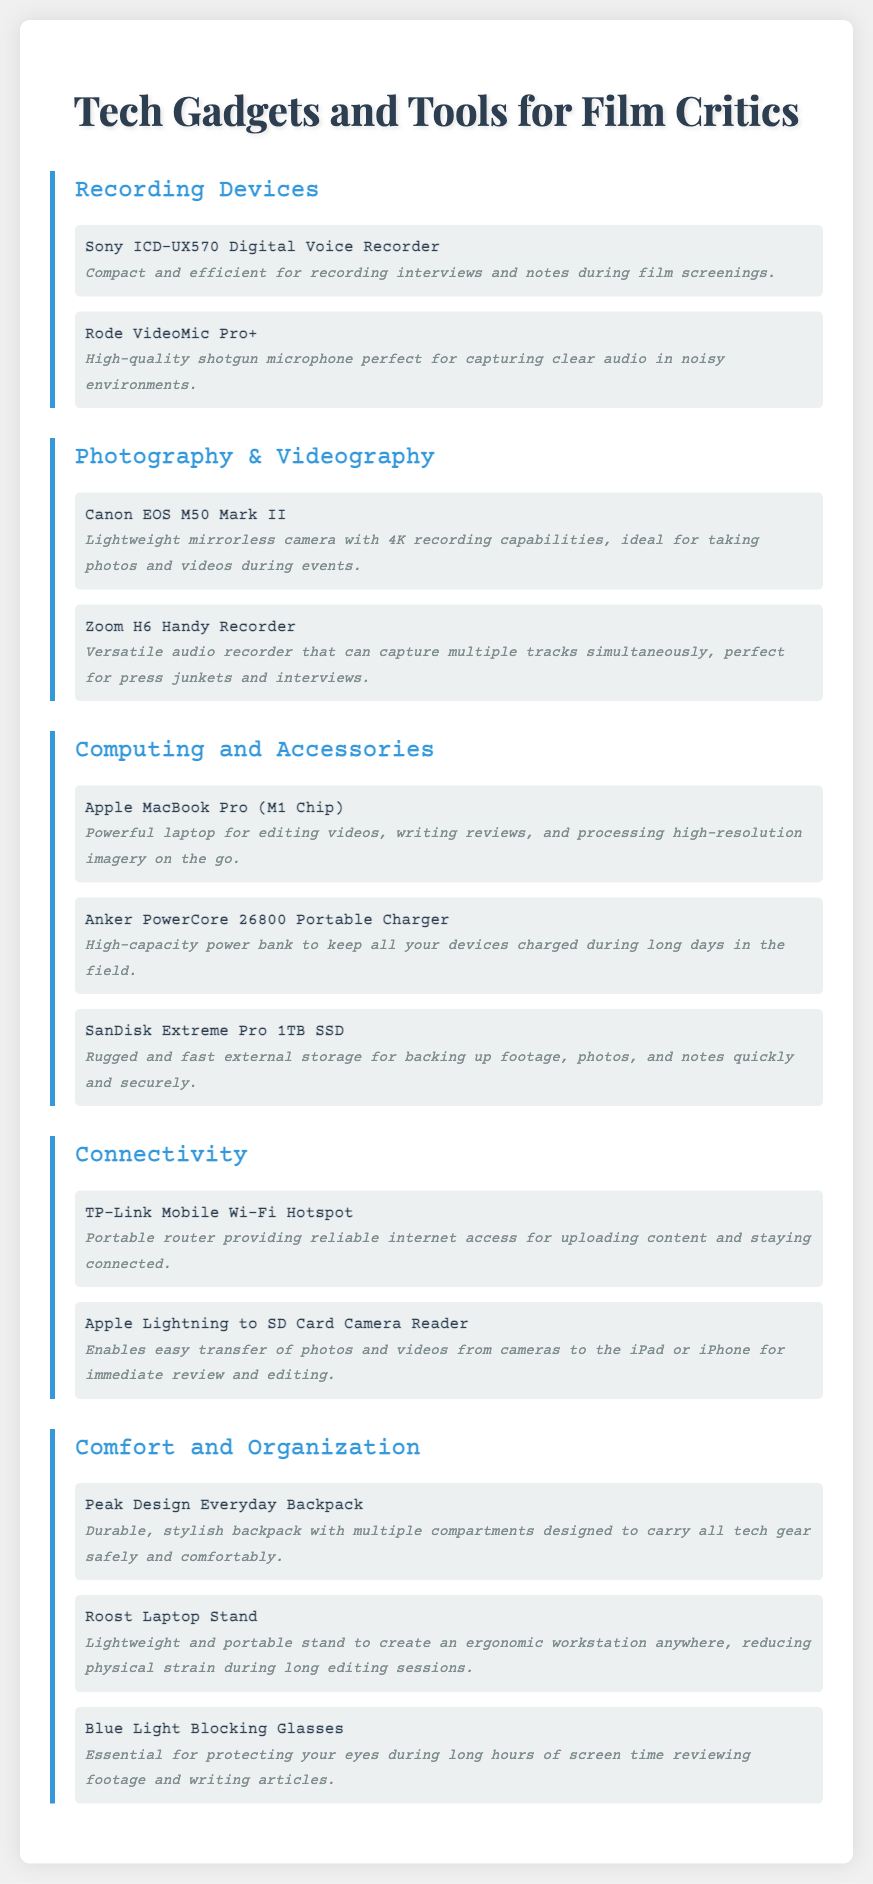what recording device is recommended for interviews? The document lists the Sony ICD-UX570 Digital Voice Recorder as a compact and efficient device for recording interviews.
Answer: Sony ICD-UX570 Digital Voice Recorder which camera is noted for 4K recording capabilities? The Canon EOS M50 Mark II is highlighted for its 4K recording capabilities.
Answer: Canon EOS M50 Mark II how many items are listed under Computing and Accessories? The document mentions three items under the Computing and Accessories category.
Answer: 3 what is the portable router mentioned for internet access? The TP-Link Mobile Wi-Fi Hotspot is identified as the portable router for reliable internet access.
Answer: TP-Link Mobile Wi-Fi Hotspot which item is described as reducing physical strain during editing sessions? The Roost Laptop Stand is noted for creating an ergonomic workstation, thereby reducing physical strain during long sessions.
Answer: Roost Laptop Stand what is the description of the PowerCore charger? The Anker PowerCore 26800 Portable Charger is described as a high-capacity power bank to keep all devices charged.
Answer: High-capacity power bank how is the Blue Light Blocking Glasses categorized? They are categorized under Comfort and Organization in the packing list.
Answer: Comfort and Organization which device is suitable for capturing multiple tracks simultaneously? The Zoom H6 Handy Recorder is specified as the versatile audio recorder for capturing multiple tracks at once.
Answer: Zoom H6 Handy Recorder 